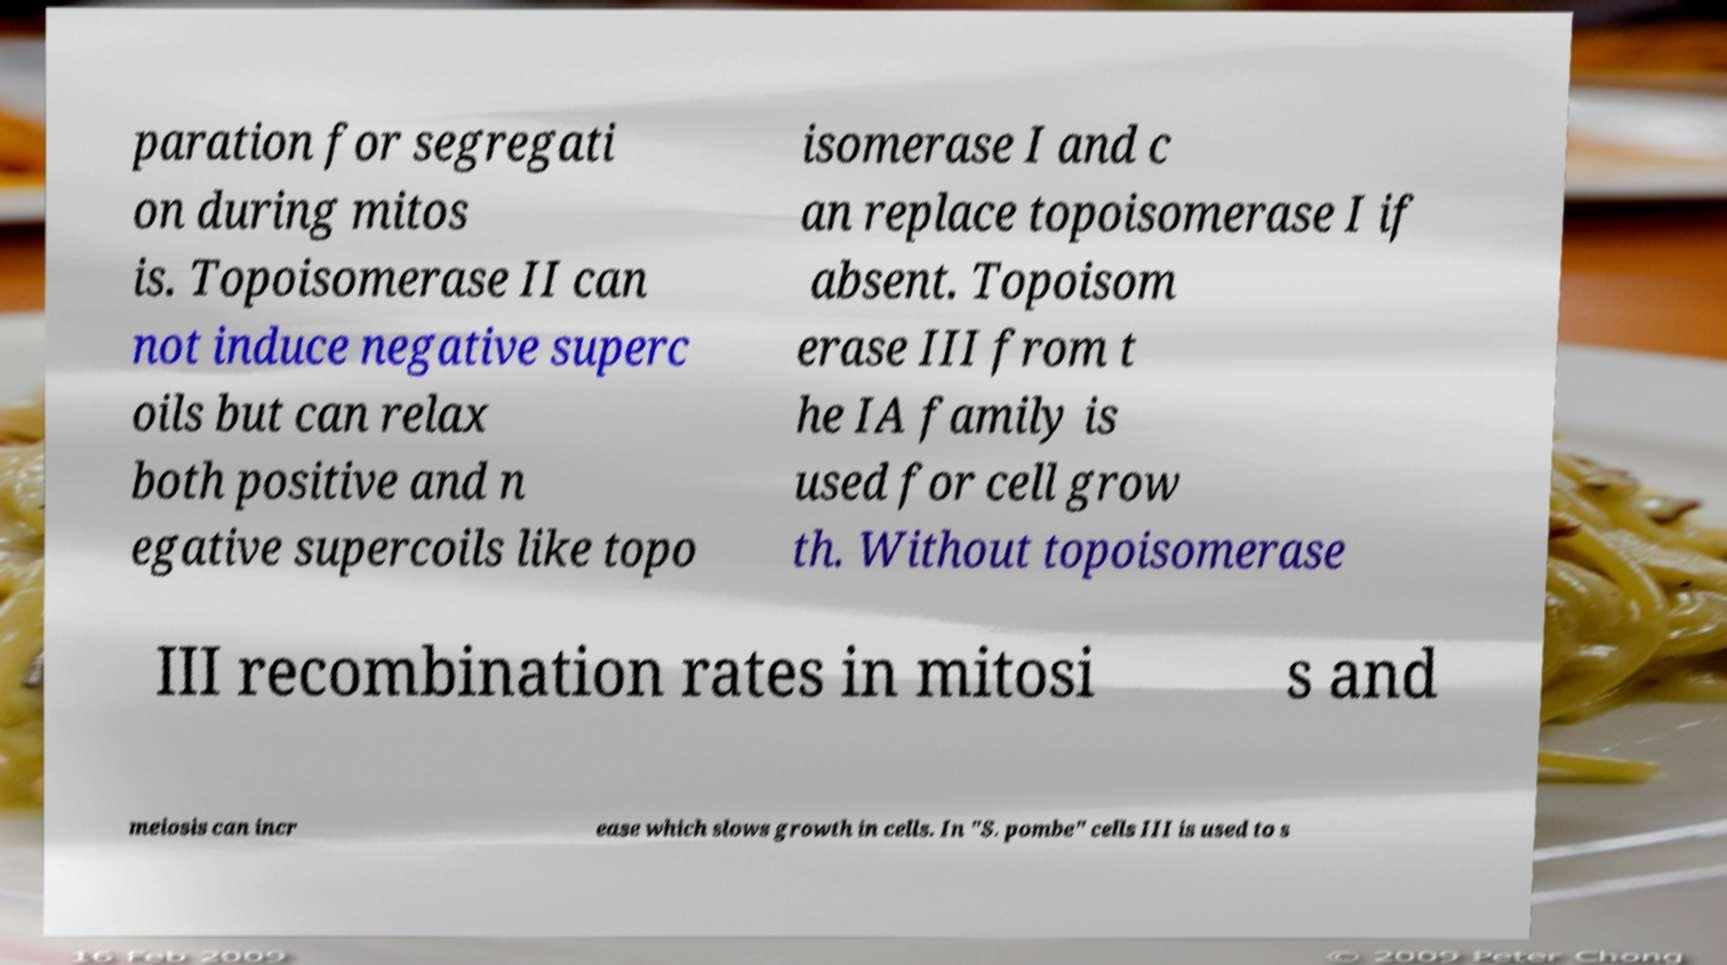I need the written content from this picture converted into text. Can you do that? paration for segregati on during mitos is. Topoisomerase II can not induce negative superc oils but can relax both positive and n egative supercoils like topo isomerase I and c an replace topoisomerase I if absent. Topoisom erase III from t he IA family is used for cell grow th. Without topoisomerase III recombination rates in mitosi s and meiosis can incr ease which slows growth in cells. In "S. pombe" cells III is used to s 